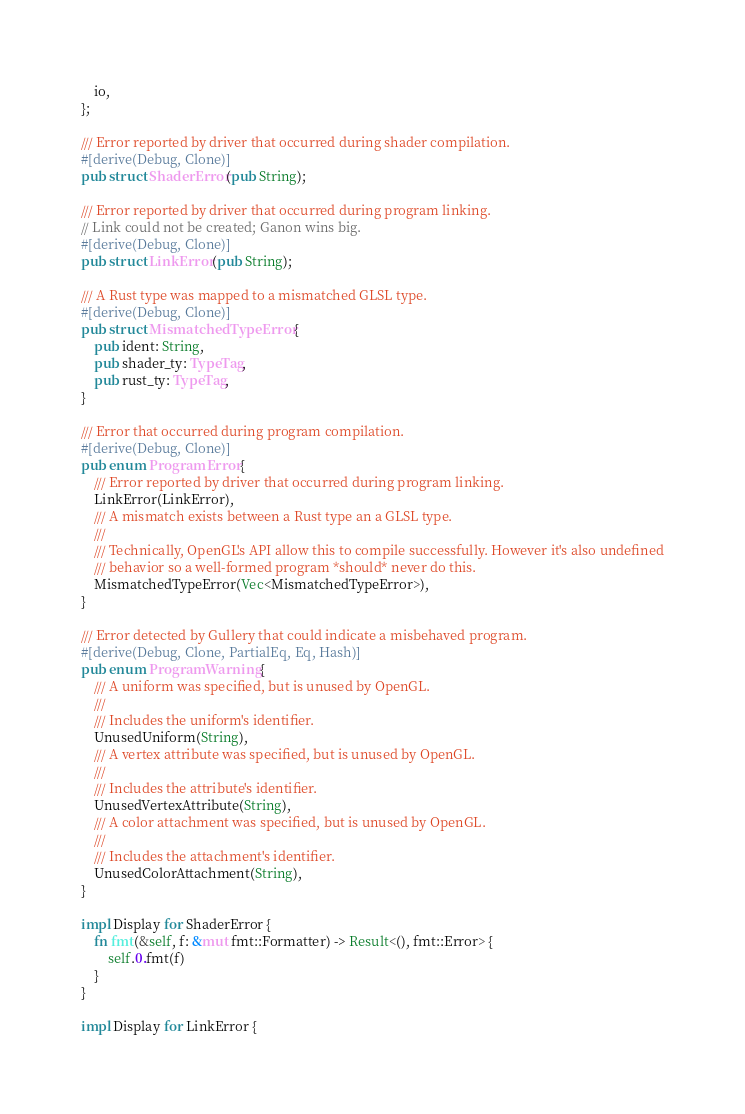Convert code to text. <code><loc_0><loc_0><loc_500><loc_500><_Rust_>    io,
};

/// Error reported by driver that occurred during shader compilation.
#[derive(Debug, Clone)]
pub struct ShaderError(pub String);

/// Error reported by driver that occurred during program linking.
// Link could not be created; Ganon wins big.
#[derive(Debug, Clone)]
pub struct LinkError(pub String);

/// A Rust type was mapped to a mismatched GLSL type.
#[derive(Debug, Clone)]
pub struct MismatchedTypeError {
    pub ident: String,
    pub shader_ty: TypeTag,
    pub rust_ty: TypeTag,
}

/// Error that occurred during program compilation.
#[derive(Debug, Clone)]
pub enum ProgramError {
    /// Error reported by driver that occurred during program linking.
    LinkError(LinkError),
    /// A mismatch exists between a Rust type an a GLSL type.
    ///
    /// Technically, OpenGL's API allow this to compile successfully. However it's also undefined
    /// behavior so a well-formed program *should* never do this.
    MismatchedTypeError(Vec<MismatchedTypeError>),
}

/// Error detected by Gullery that could indicate a misbehaved program.
#[derive(Debug, Clone, PartialEq, Eq, Hash)]
pub enum ProgramWarning {
    /// A uniform was specified, but is unused by OpenGL.
    ///
    /// Includes the uniform's identifier.
    UnusedUniform(String),
    /// A vertex attribute was specified, but is unused by OpenGL.
    ///
    /// Includes the attribute's identifier.
    UnusedVertexAttribute(String),
    /// A color attachment was specified, but is unused by OpenGL.
    ///
    /// Includes the attachment's identifier.
    UnusedColorAttachment(String),
}

impl Display for ShaderError {
    fn fmt(&self, f: &mut fmt::Formatter) -> Result<(), fmt::Error> {
        self.0.fmt(f)
    }
}

impl Display for LinkError {</code> 